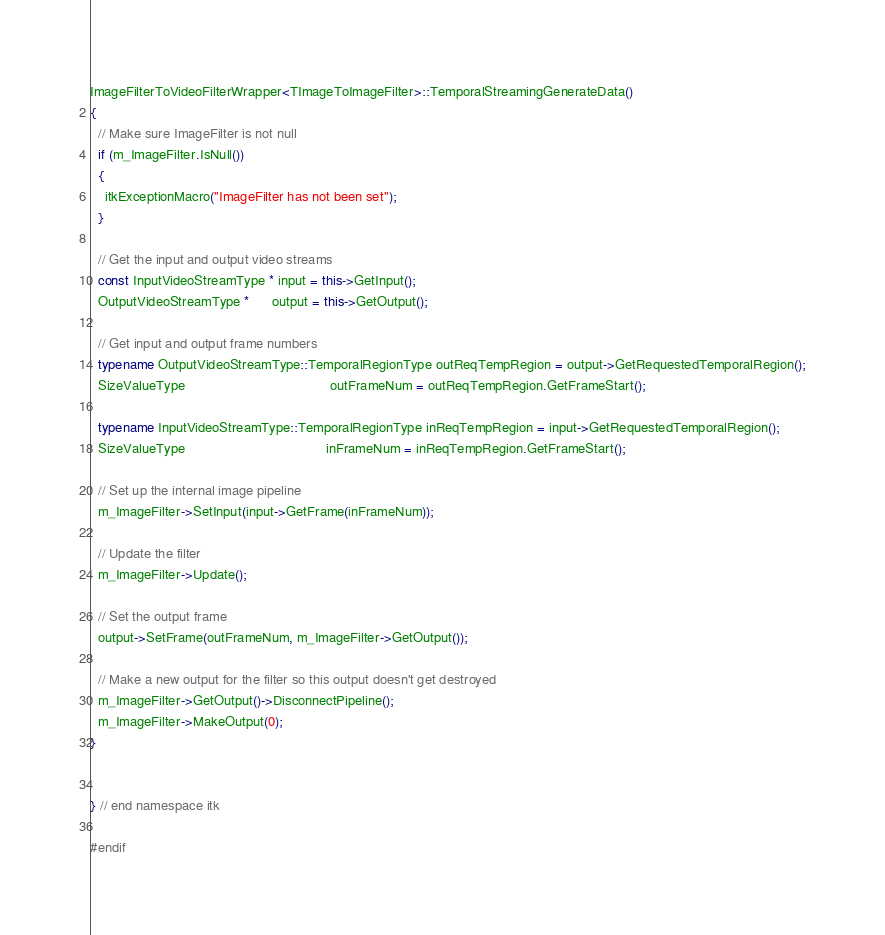<code> <loc_0><loc_0><loc_500><loc_500><_C++_>ImageFilterToVideoFilterWrapper<TImageToImageFilter>::TemporalStreamingGenerateData()
{
  // Make sure ImageFilter is not null
  if (m_ImageFilter.IsNull())
  {
    itkExceptionMacro("ImageFilter has not been set");
  }

  // Get the input and output video streams
  const InputVideoStreamType * input = this->GetInput();
  OutputVideoStreamType *      output = this->GetOutput();

  // Get input and output frame numbers
  typename OutputVideoStreamType::TemporalRegionType outReqTempRegion = output->GetRequestedTemporalRegion();
  SizeValueType                                      outFrameNum = outReqTempRegion.GetFrameStart();

  typename InputVideoStreamType::TemporalRegionType inReqTempRegion = input->GetRequestedTemporalRegion();
  SizeValueType                                     inFrameNum = inReqTempRegion.GetFrameStart();

  // Set up the internal image pipeline
  m_ImageFilter->SetInput(input->GetFrame(inFrameNum));

  // Update the filter
  m_ImageFilter->Update();

  // Set the output frame
  output->SetFrame(outFrameNum, m_ImageFilter->GetOutput());

  // Make a new output for the filter so this output doesn't get destroyed
  m_ImageFilter->GetOutput()->DisconnectPipeline();
  m_ImageFilter->MakeOutput(0);
}


} // end namespace itk

#endif
</code> 